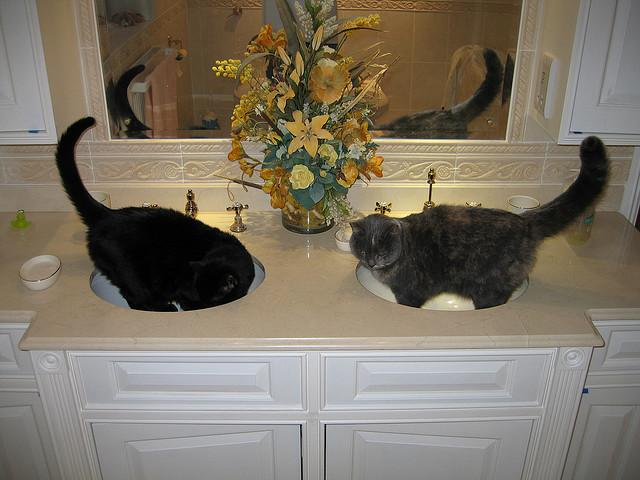Where are the cats playing?

Choices:
A) sink
B) sand
C) river
D) parking lot sink 